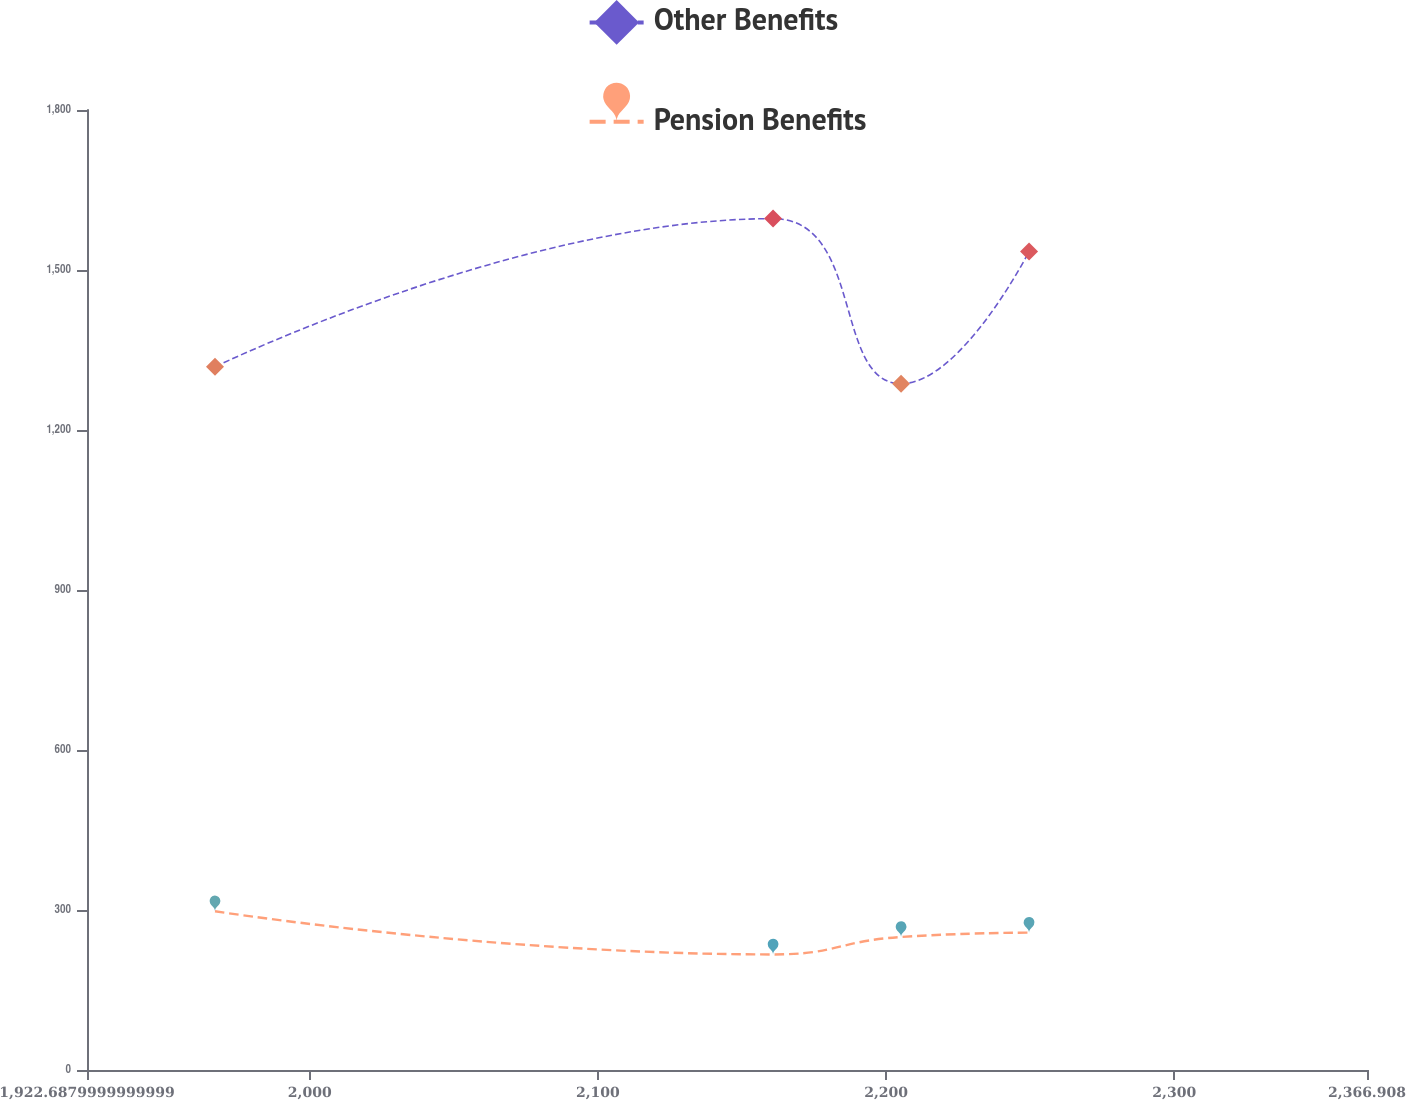Convert chart to OTSL. <chart><loc_0><loc_0><loc_500><loc_500><line_chart><ecel><fcel>Other Benefits<fcel>Pension Benefits<nl><fcel>1967.11<fcel>1318.44<fcel>297.65<nl><fcel>2160.79<fcel>1596.33<fcel>216.65<nl><fcel>2205.21<fcel>1286.81<fcel>249.42<nl><fcel>2249.63<fcel>1534.5<fcel>257.52<nl><fcel>2411.33<fcel>1475.48<fcel>270.31<nl></chart> 